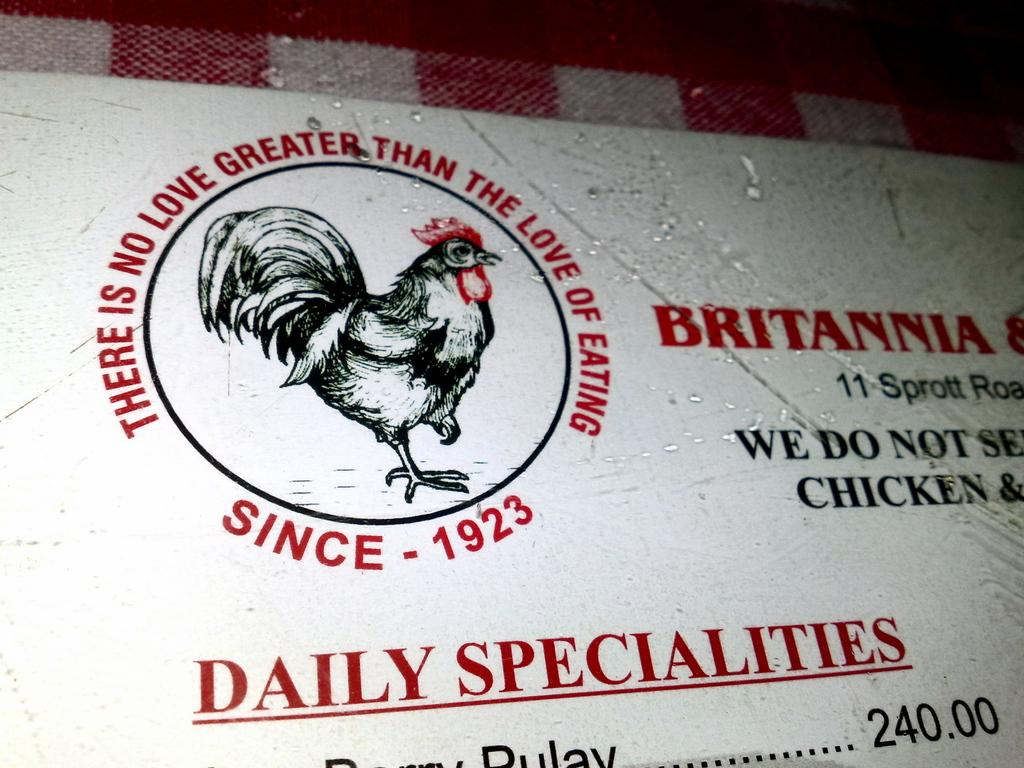What is the main object in the image? There is a board in the image. What is featured on the board? There is a logo and text on the board. What type of watch can be seen on the board in the image? There is no watch present on the board in the image. How many ducks are visible on the board in the image? There are no ducks present on the board in the image. 